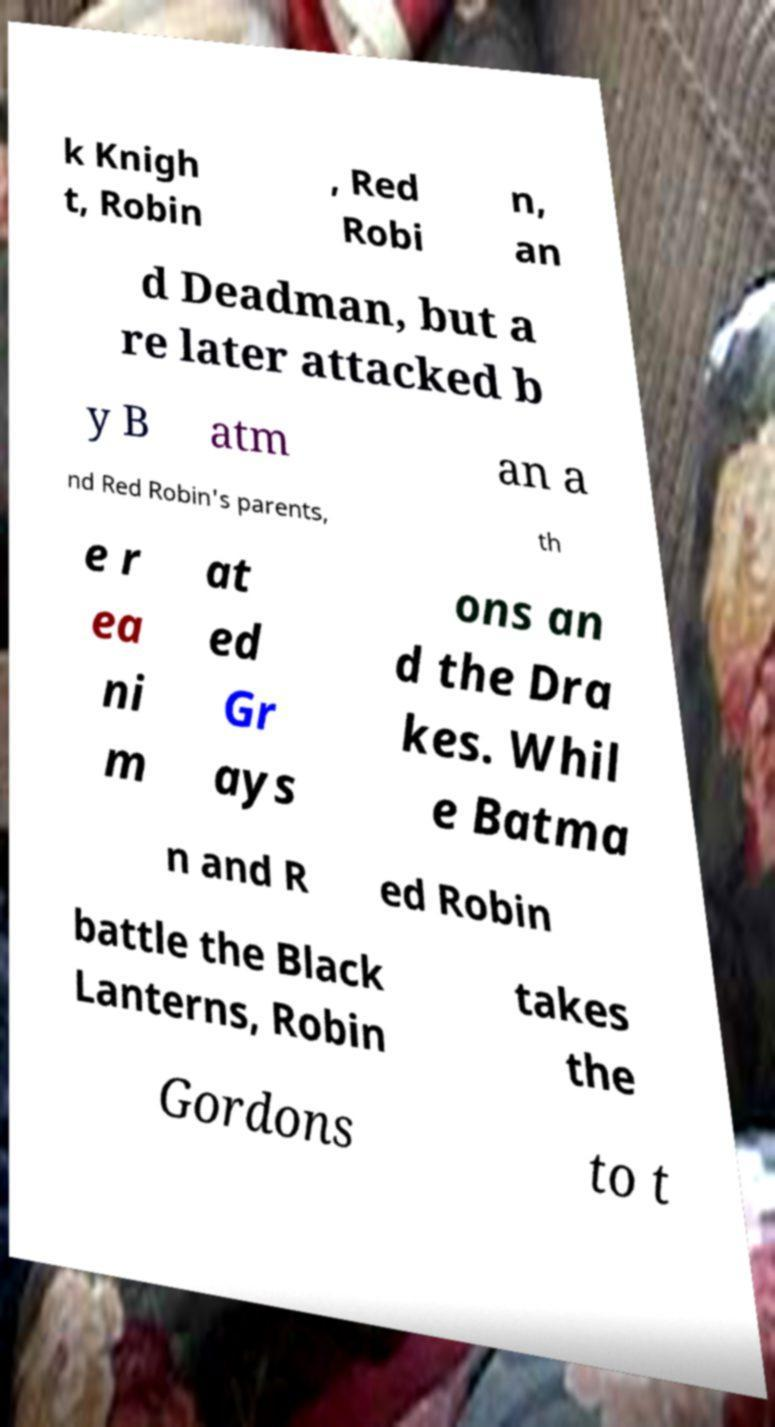Please identify and transcribe the text found in this image. k Knigh t, Robin , Red Robi n, an d Deadman, but a re later attacked b y B atm an a nd Red Robin's parents, th e r ea ni m at ed Gr ays ons an d the Dra kes. Whil e Batma n and R ed Robin battle the Black Lanterns, Robin takes the Gordons to t 